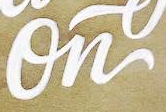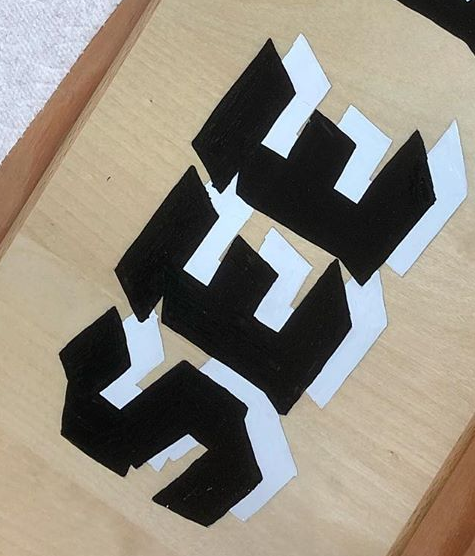Transcribe the words shown in these images in order, separated by a semicolon. On; SEE 